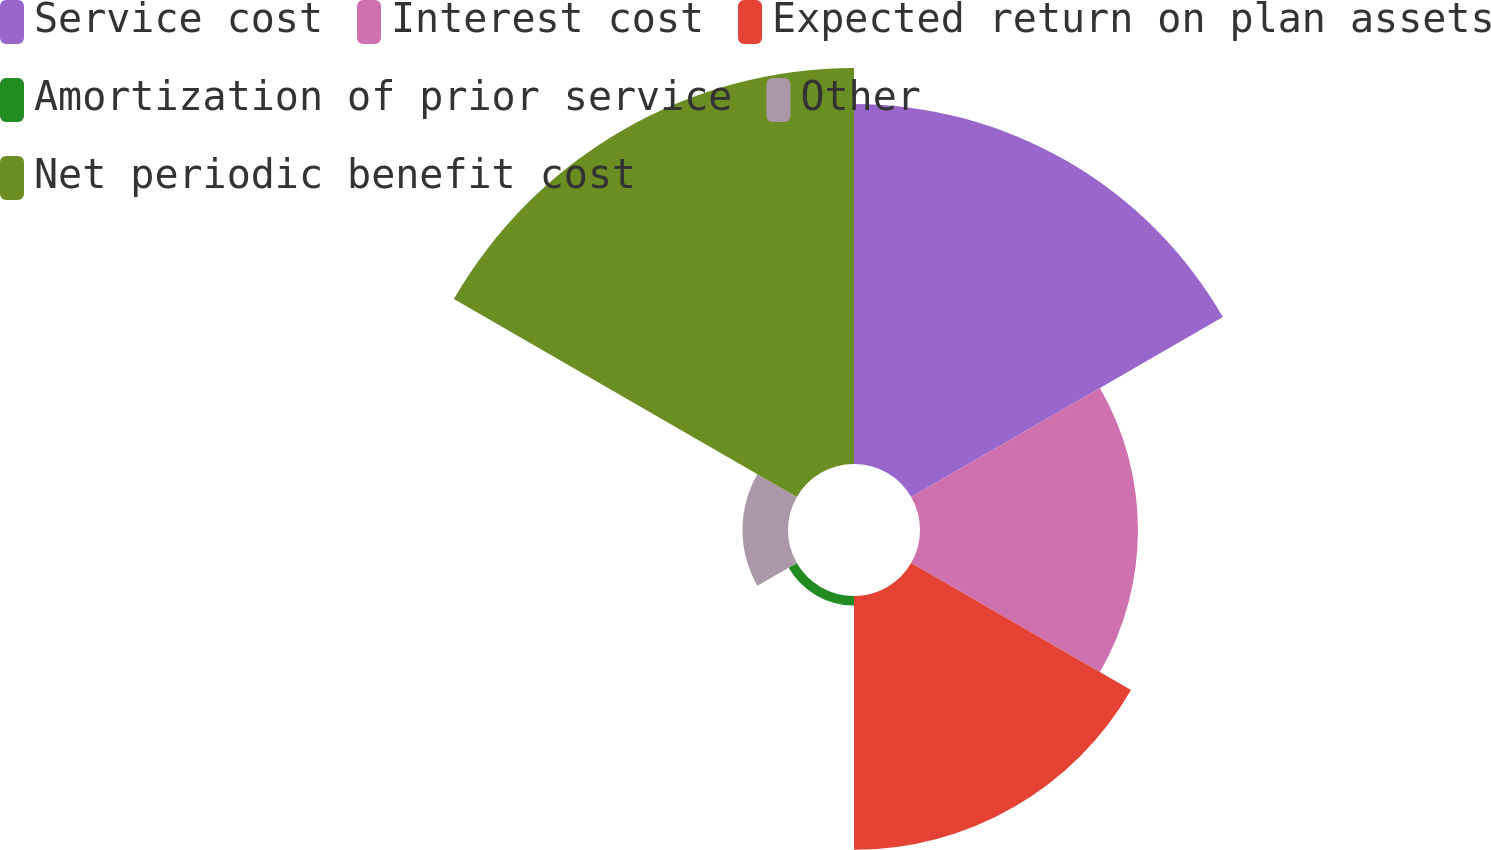Convert chart. <chart><loc_0><loc_0><loc_500><loc_500><pie_chart><fcel>Service cost<fcel>Interest cost<fcel>Expected return on plan assets<fcel>Amortization of prior service<fcel>Other<fcel>Net periodic benefit cost<nl><fcel>28.06%<fcel>16.99%<fcel>19.79%<fcel>0.74%<fcel>3.55%<fcel>30.87%<nl></chart> 